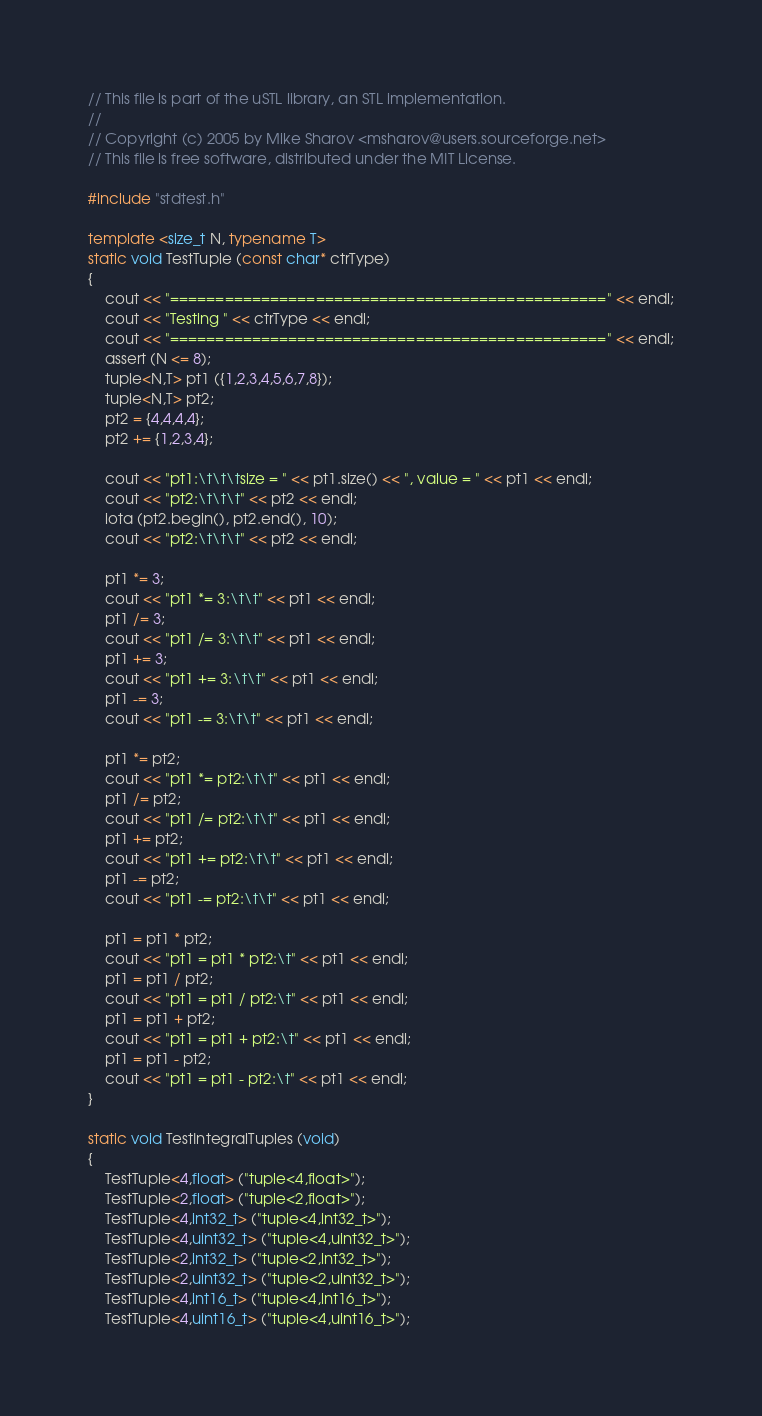Convert code to text. <code><loc_0><loc_0><loc_500><loc_500><_C++_>// This file is part of the uSTL library, an STL implementation.
//
// Copyright (c) 2005 by Mike Sharov <msharov@users.sourceforge.net>
// This file is free software, distributed under the MIT License.

#include "stdtest.h"

template <size_t N, typename T>
static void TestTuple (const char* ctrType)
{
    cout << "================================================" << endl;
    cout << "Testing " << ctrType << endl;
    cout << "================================================" << endl;
    assert (N <= 8);
    tuple<N,T> pt1 ({1,2,3,4,5,6,7,8});
    tuple<N,T> pt2;
    pt2 = {4,4,4,4};
    pt2 += {1,2,3,4};

    cout << "pt1:\t\t\tsize = " << pt1.size() << ", value = " << pt1 << endl;
    cout << "pt2:\t\t\t" << pt2 << endl;
    iota (pt2.begin(), pt2.end(), 10);
    cout << "pt2:\t\t\t" << pt2 << endl;

    pt1 *= 3;
    cout << "pt1 *= 3:\t\t" << pt1 << endl;
    pt1 /= 3;
    cout << "pt1 /= 3:\t\t" << pt1 << endl;
    pt1 += 3;
    cout << "pt1 += 3:\t\t" << pt1 << endl;
    pt1 -= 3;
    cout << "pt1 -= 3:\t\t" << pt1 << endl;

    pt1 *= pt2;
    cout << "pt1 *= pt2:\t\t" << pt1 << endl;
    pt1 /= pt2;
    cout << "pt1 /= pt2:\t\t" << pt1 << endl;
    pt1 += pt2;
    cout << "pt1 += pt2:\t\t" << pt1 << endl;
    pt1 -= pt2;
    cout << "pt1 -= pt2:\t\t" << pt1 << endl;

    pt1 = pt1 * pt2;
    cout << "pt1 = pt1 * pt2:\t" << pt1 << endl;
    pt1 = pt1 / pt2;
    cout << "pt1 = pt1 / pt2:\t" << pt1 << endl;
    pt1 = pt1 + pt2;
    cout << "pt1 = pt1 + pt2:\t" << pt1 << endl;
    pt1 = pt1 - pt2;
    cout << "pt1 = pt1 - pt2:\t" << pt1 << endl;
}

static void TestIntegralTuples (void)
{
    TestTuple<4,float> ("tuple<4,float>");
    TestTuple<2,float> ("tuple<2,float>");
    TestTuple<4,int32_t> ("tuple<4,int32_t>");
    TestTuple<4,uint32_t> ("tuple<4,uint32_t>");
    TestTuple<2,int32_t> ("tuple<2,int32_t>");
    TestTuple<2,uint32_t> ("tuple<2,uint32_t>");
    TestTuple<4,int16_t> ("tuple<4,int16_t>");
    TestTuple<4,uint16_t> ("tuple<4,uint16_t>");</code> 